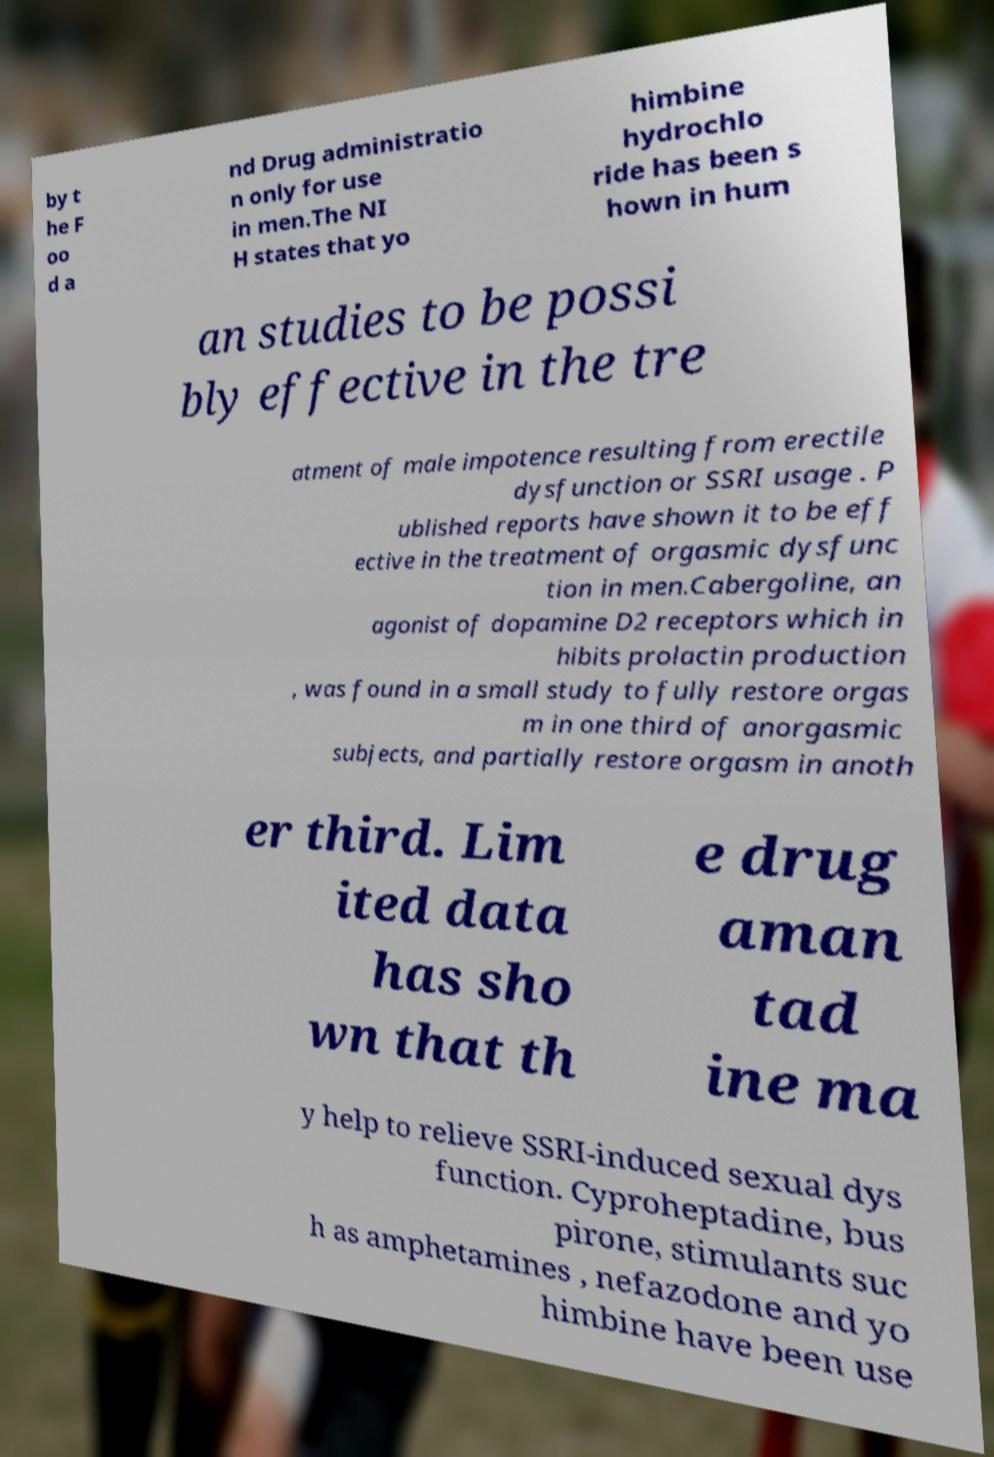For documentation purposes, I need the text within this image transcribed. Could you provide that? by t he F oo d a nd Drug administratio n only for use in men.The NI H states that yo himbine hydrochlo ride has been s hown in hum an studies to be possi bly effective in the tre atment of male impotence resulting from erectile dysfunction or SSRI usage . P ublished reports have shown it to be eff ective in the treatment of orgasmic dysfunc tion in men.Cabergoline, an agonist of dopamine D2 receptors which in hibits prolactin production , was found in a small study to fully restore orgas m in one third of anorgasmic subjects, and partially restore orgasm in anoth er third. Lim ited data has sho wn that th e drug aman tad ine ma y help to relieve SSRI-induced sexual dys function. Cyproheptadine, bus pirone, stimulants suc h as amphetamines , nefazodone and yo himbine have been use 